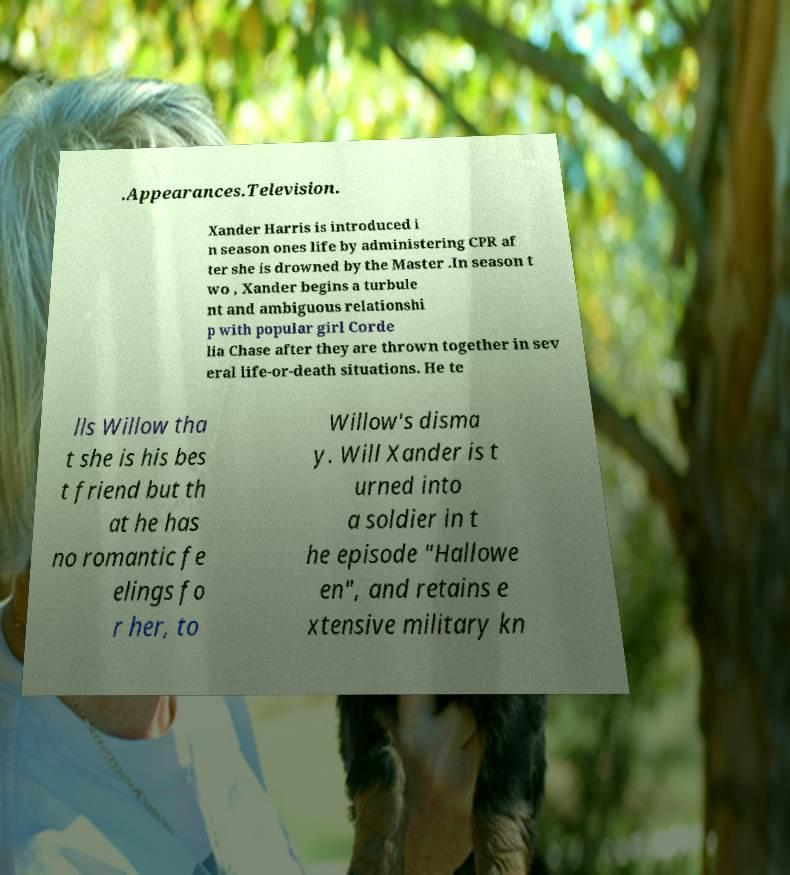There's text embedded in this image that I need extracted. Can you transcribe it verbatim? .Appearances.Television. Xander Harris is introduced i n season ones life by administering CPR af ter she is drowned by the Master .In season t wo , Xander begins a turbule nt and ambiguous relationshi p with popular girl Corde lia Chase after they are thrown together in sev eral life-or-death situations. He te lls Willow tha t she is his bes t friend but th at he has no romantic fe elings fo r her, to Willow's disma y. Will Xander is t urned into a soldier in t he episode "Hallowe en", and retains e xtensive military kn 